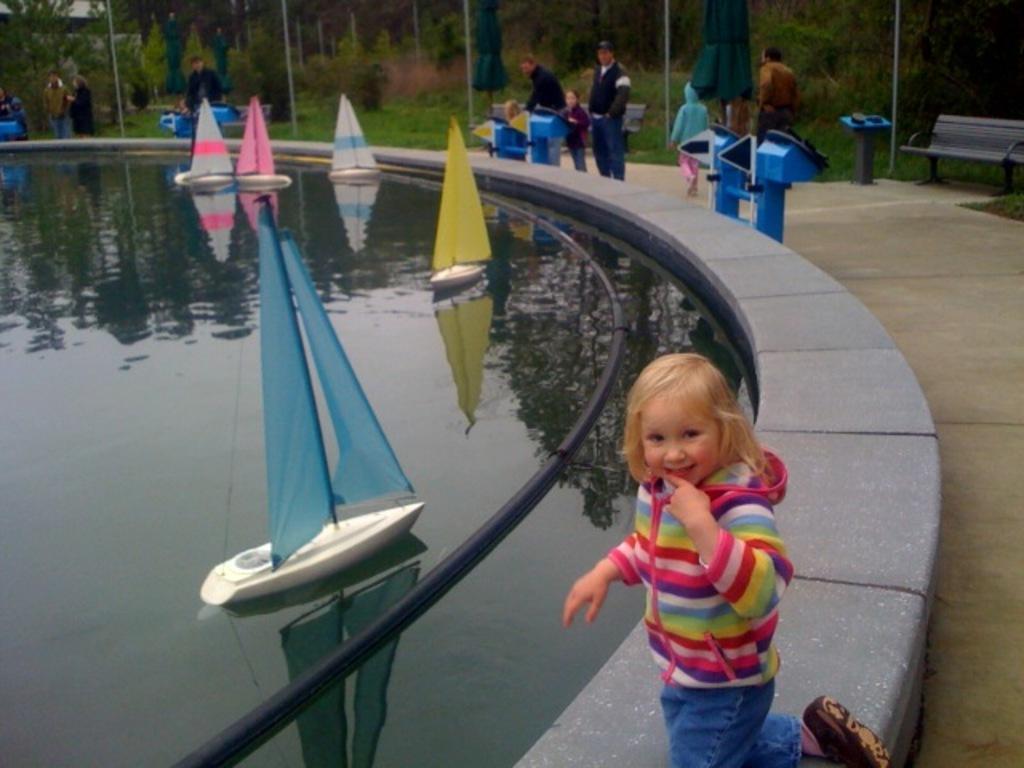In one or two sentences, can you explain what this image depicts? In this image I can see few boats on the water surface. I can see few people, trees, bench, poles, umbrellas and few objects in blue and black color. 